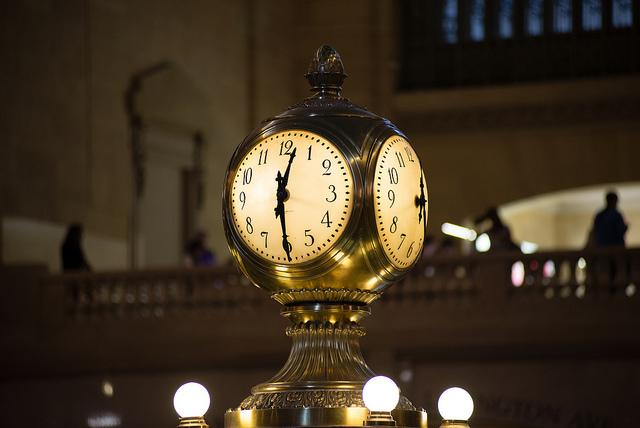If the clock is showing times in the PM how many hours ago did the New York Stock Exchange open? three 